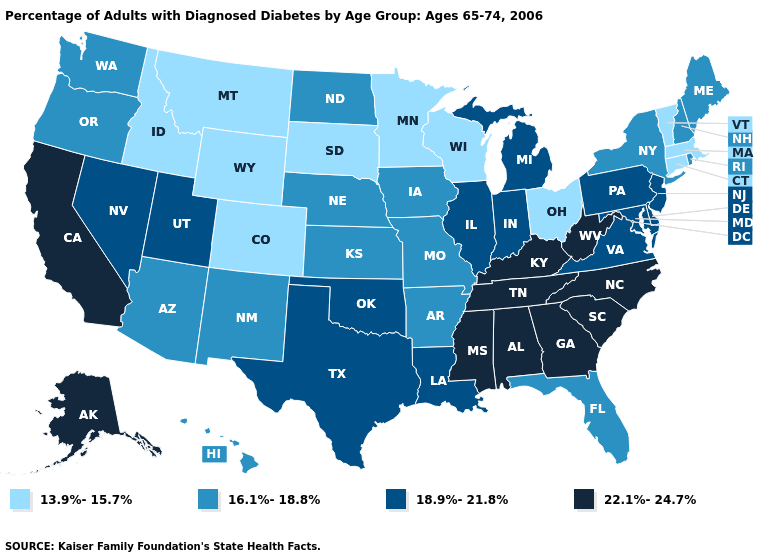What is the lowest value in the USA?
Give a very brief answer. 13.9%-15.7%. What is the value of Kentucky?
Short answer required. 22.1%-24.7%. Name the states that have a value in the range 18.9%-21.8%?
Short answer required. Delaware, Illinois, Indiana, Louisiana, Maryland, Michigan, Nevada, New Jersey, Oklahoma, Pennsylvania, Texas, Utah, Virginia. What is the value of Kansas?
Give a very brief answer. 16.1%-18.8%. Name the states that have a value in the range 16.1%-18.8%?
Answer briefly. Arizona, Arkansas, Florida, Hawaii, Iowa, Kansas, Maine, Missouri, Nebraska, New Hampshire, New Mexico, New York, North Dakota, Oregon, Rhode Island, Washington. What is the highest value in the West ?
Quick response, please. 22.1%-24.7%. What is the value of West Virginia?
Quick response, please. 22.1%-24.7%. What is the value of Delaware?
Write a very short answer. 18.9%-21.8%. What is the value of Mississippi?
Be succinct. 22.1%-24.7%. Among the states that border Maryland , does Pennsylvania have the lowest value?
Keep it brief. Yes. Name the states that have a value in the range 18.9%-21.8%?
Be succinct. Delaware, Illinois, Indiana, Louisiana, Maryland, Michigan, Nevada, New Jersey, Oklahoma, Pennsylvania, Texas, Utah, Virginia. What is the lowest value in the MidWest?
Short answer required. 13.9%-15.7%. What is the highest value in states that border South Dakota?
Keep it brief. 16.1%-18.8%. 